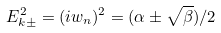<formula> <loc_0><loc_0><loc_500><loc_500>E _ { k \pm } ^ { 2 } = ( i w _ { n } ) ^ { 2 } = ( \alpha \pm \sqrt { \beta } ) / 2</formula> 